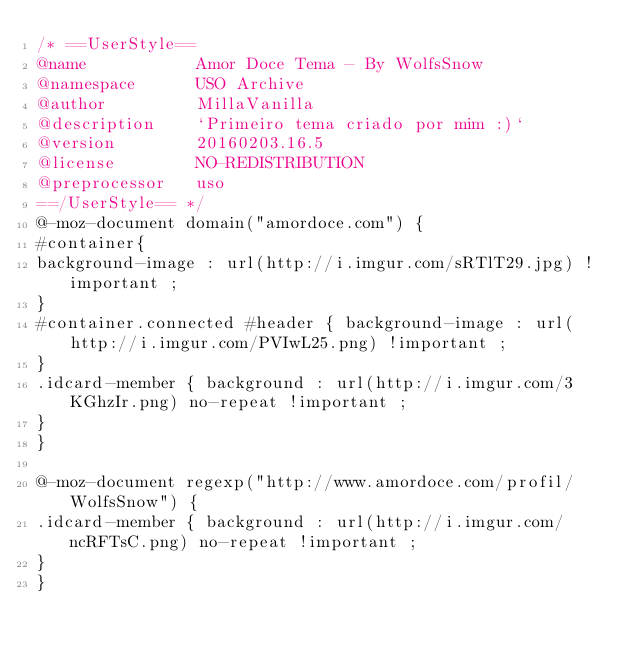Convert code to text. <code><loc_0><loc_0><loc_500><loc_500><_CSS_>/* ==UserStyle==
@name           Amor Doce Tema - By WolfsSnow
@namespace      USO Archive
@author         MillaVanilla
@description    `Primeiro tema criado por mim :)`
@version        20160203.16.5
@license        NO-REDISTRIBUTION
@preprocessor   uso
==/UserStyle== */
@-moz-document domain("amordoce.com") {
#container{
background-image : url(http://i.imgur.com/sRTlT29.jpg) !important ;
}
#container.connected #header { background-image : url(http://i.imgur.com/PVIwL25.png) !important ;
}
.idcard-member { background : url(http://i.imgur.com/3KGhzIr.png) no-repeat !important ;
}
}

@-moz-document regexp("http://www.amordoce.com/profil/WolfsSnow") {
.idcard-member { background : url(http://i.imgur.com/ncRFTsC.png) no-repeat !important ;
}
}</code> 